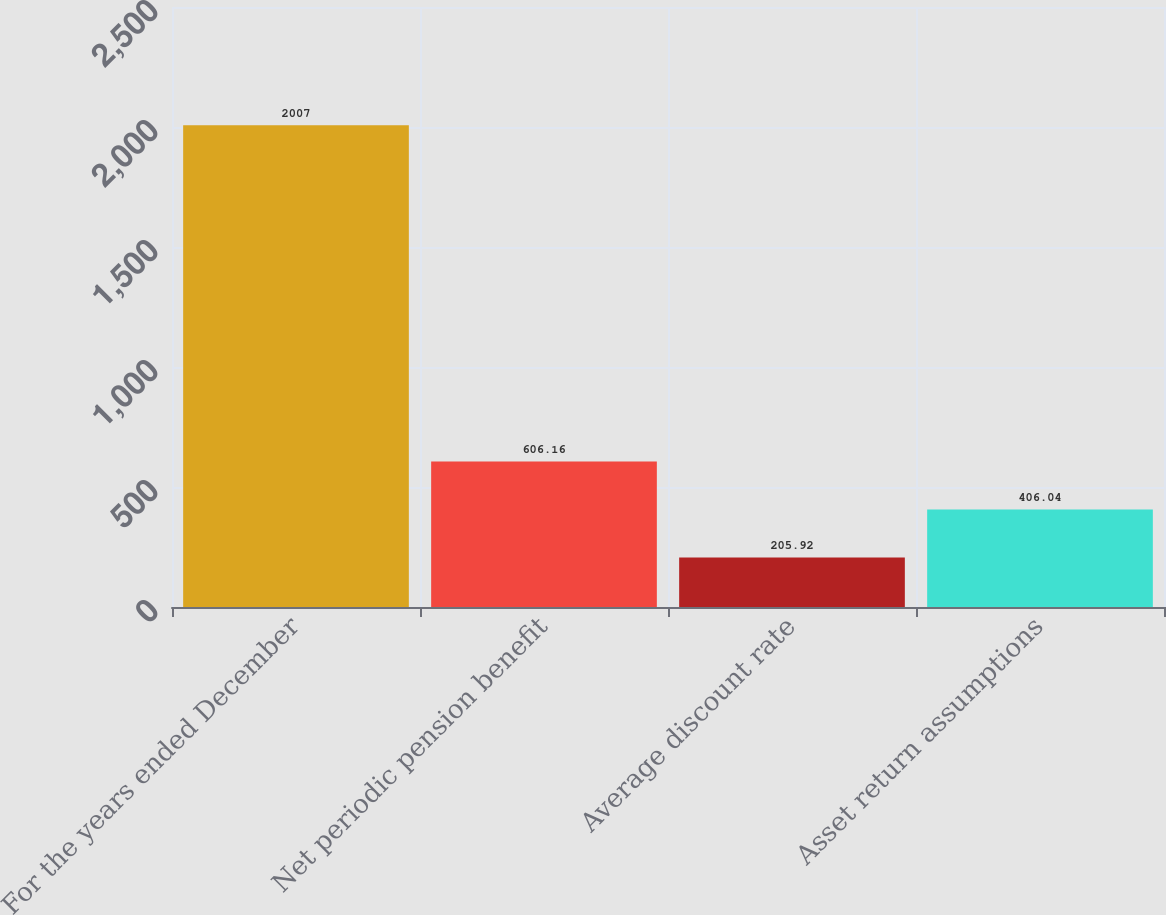Convert chart. <chart><loc_0><loc_0><loc_500><loc_500><bar_chart><fcel>For the years ended December<fcel>Net periodic pension benefit<fcel>Average discount rate<fcel>Asset return assumptions<nl><fcel>2007<fcel>606.16<fcel>205.92<fcel>406.04<nl></chart> 